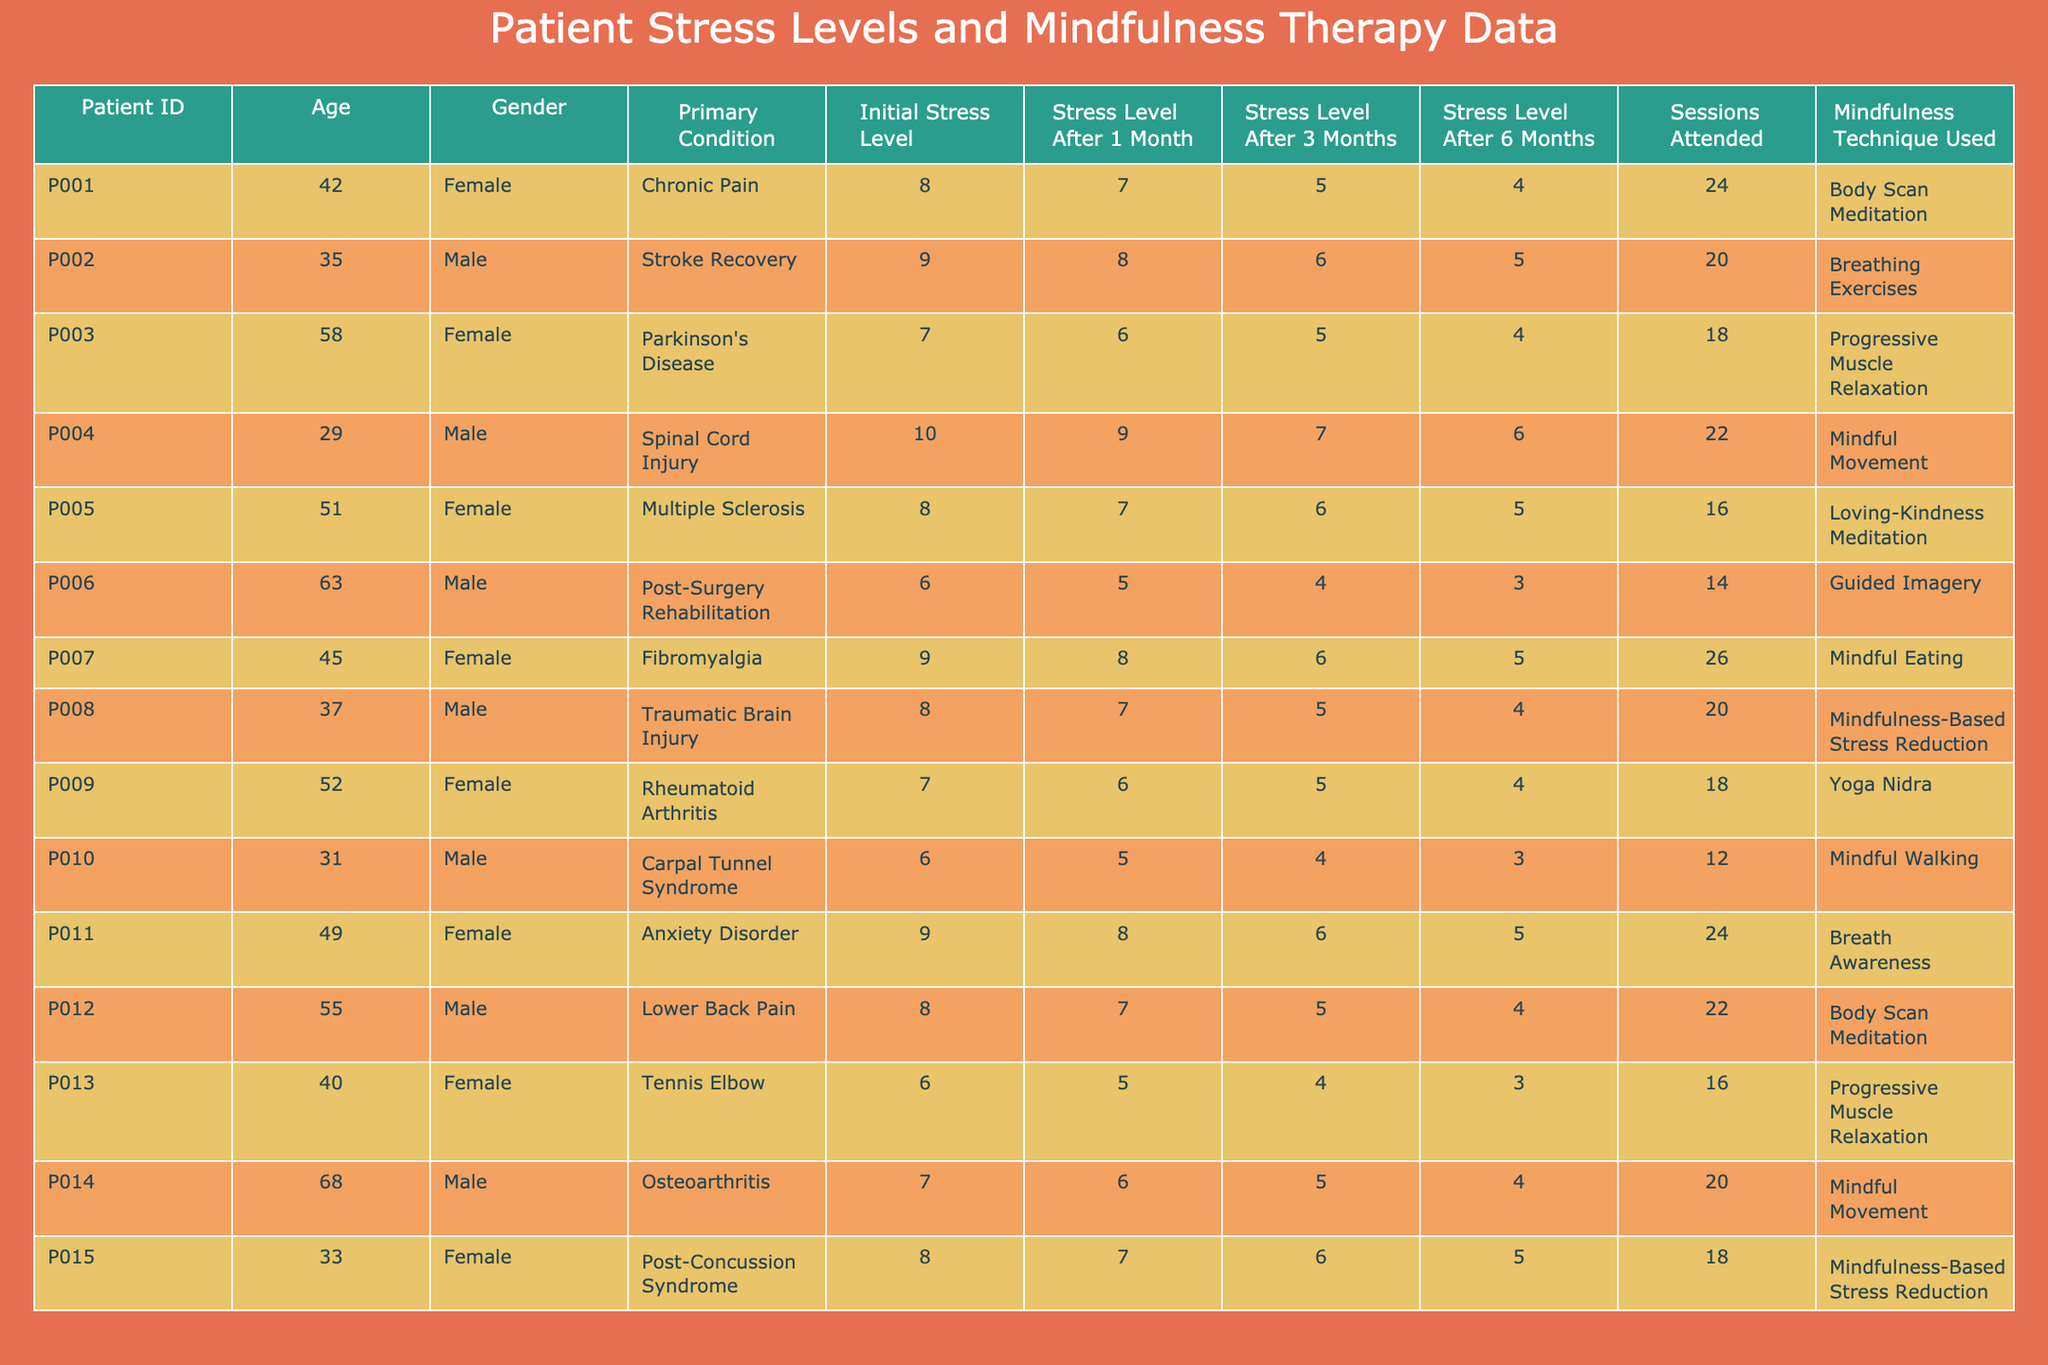What is the initial stress level of Patient P008? To find this information, locate Patient P008 in the table and look at the "Initial Stress Level" column. The initial stress level for Patient P008 is 8.
Answer: 8 Which mindfulness technique was used by Patient P003? By scanning the table for Patient P003, I check the "Mindfulness Technique Used" column, which shows that Patient P003 utilized Progressive Muscle Relaxation.
Answer: Progressive Muscle Relaxation What is the stress level after 6 months for the youngest patient? First, identify the youngest patient by checking the "Age" column. Patient P004, who is 29 years old, has a stress level after 6 months of 6.
Answer: 6 How many patients attended more than 20 sessions? Look through the "Sessions Attended" column to count how many entries exceed 20. Upon review, 6 patients attended more than 20 sessions.
Answer: 6 Is there any patient whose initial stress level was 10? Check the "Initial Stress Level" column for a value of 10. Patient P004 has an initial stress level of 10, confirming it's true.
Answer: Yes What is the average stress level after 1 month for all patients? To find the average, sum all values in the "Stress Level After 1 Month" column (7 + 8 + 6 + 9 + 7 + 5 + 8 + 7 + 6 + 5 + 8 + 7 + 5 + 6 + 7) = 103, then divide by the total number of patients (15): 103/15 = 6.87.
Answer: 6.87 What is the difference in stress levels after 3 months between the oldest and the youngest patient? Locate the stress levels after 3 months for the oldest patient (P014, age 68, stress level 5) and the youngest patient (P004, age 29, stress level 7). The difference is 7 - 5 = 2.
Answer: 2 Which gender has the highest initial stress level and what is that level? By checking the "Initial Stress Level" data for males (9, 10, 6, 9, 8) and females (8, 7, 7, 6, 9) the highest initial stress level is 10 from a male patient (P004).
Answer: Male; 10 How many mindfulness techniques showed a reduction in stress levels after 6 months compared to the initial levels? By analyzing the data, compare the "Initial Stress Level" and "Stress Level After 6 Months" for all patients. Out of 15 patients, 12 had reduced stress levels, meaning the techniques were effective.
Answer: 12 Is the stress level after 3 months lower for females compared to males, on average? First, calculate the average after 3 months for males (6 + 5 + 4 + 6 + 5 + 5 + 5) = 5.42, and females (6 + 6 + 5 + 6 + 6 + 7 + 7) = 6.43. The average for males is lower than females, answering the question negatively.
Answer: No 